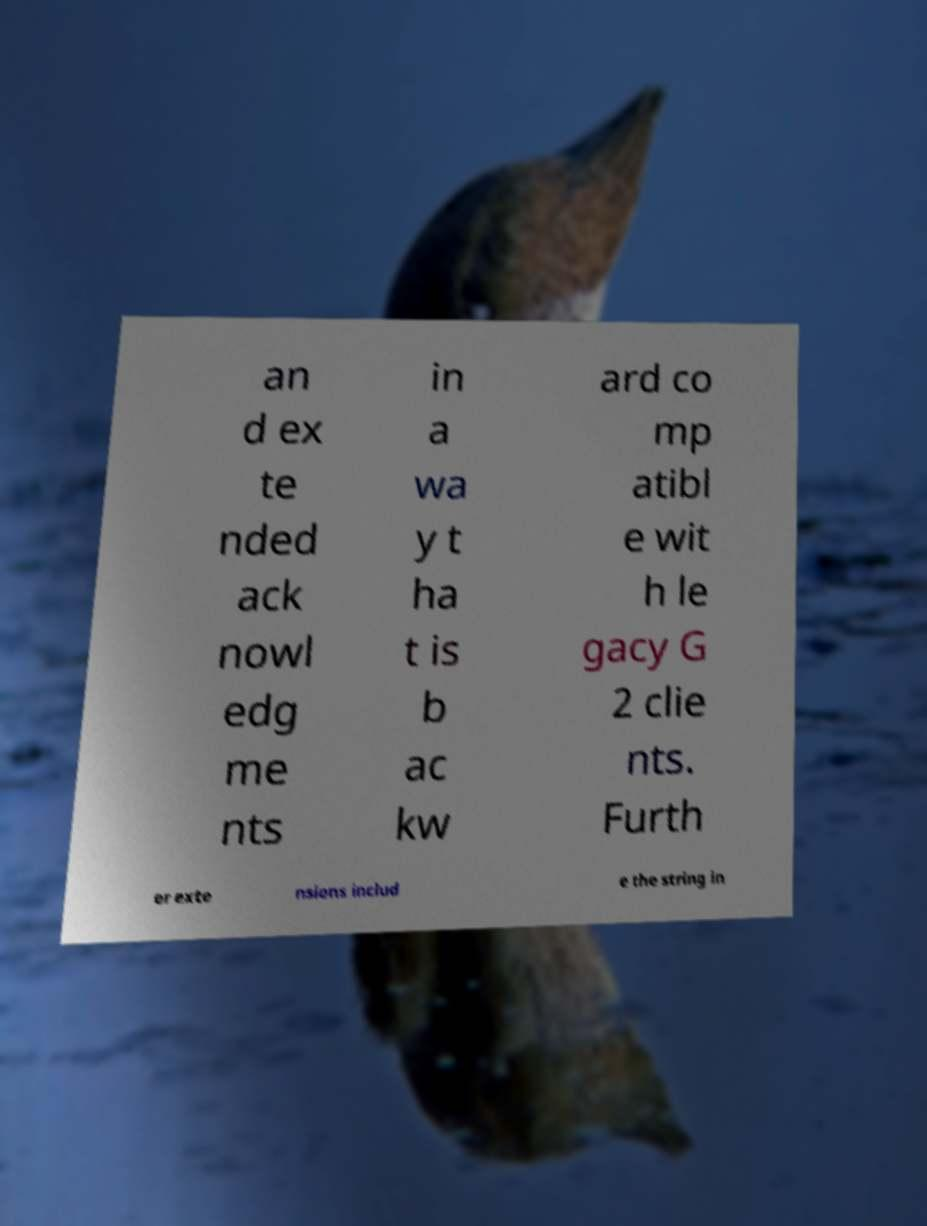Can you accurately transcribe the text from the provided image for me? an d ex te nded ack nowl edg me nts in a wa y t ha t is b ac kw ard co mp atibl e wit h le gacy G 2 clie nts. Furth er exte nsions includ e the string in 